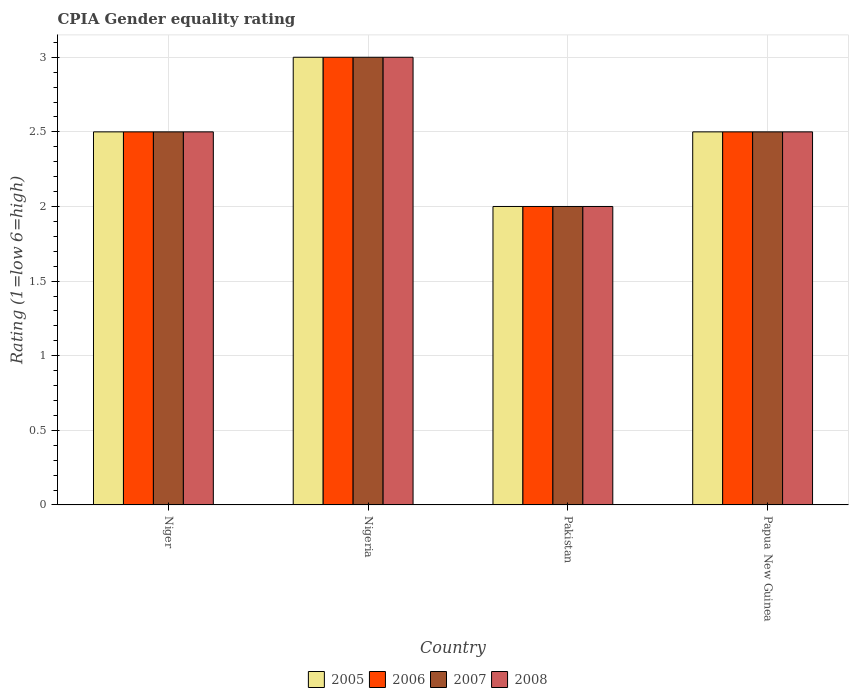How many different coloured bars are there?
Offer a terse response. 4. How many groups of bars are there?
Offer a very short reply. 4. Are the number of bars on each tick of the X-axis equal?
Give a very brief answer. Yes. How many bars are there on the 3rd tick from the left?
Offer a very short reply. 4. What is the label of the 1st group of bars from the left?
Your answer should be very brief. Niger. What is the CPIA rating in 2006 in Pakistan?
Offer a terse response. 2. Across all countries, what is the minimum CPIA rating in 2007?
Keep it short and to the point. 2. In which country was the CPIA rating in 2007 maximum?
Your answer should be compact. Nigeria. What is the difference between the CPIA rating in 2005 in Niger and that in Nigeria?
Your response must be concise. -0.5. What is the difference between the CPIA rating in 2005 in Niger and the CPIA rating in 2006 in Papua New Guinea?
Provide a short and direct response. 0. What is the difference between the CPIA rating of/in 2008 and CPIA rating of/in 2007 in Papua New Guinea?
Your answer should be very brief. 0. In how many countries, is the CPIA rating in 2007 greater than 1.5?
Ensure brevity in your answer.  4. What is the ratio of the CPIA rating in 2007 in Nigeria to that in Papua New Guinea?
Your answer should be very brief. 1.2. What is the difference between the highest and the second highest CPIA rating in 2008?
Offer a very short reply. -0.5. What is the difference between the highest and the lowest CPIA rating in 2007?
Give a very brief answer. 1. Is the sum of the CPIA rating in 2008 in Nigeria and Papua New Guinea greater than the maximum CPIA rating in 2007 across all countries?
Provide a succinct answer. Yes. Is it the case that in every country, the sum of the CPIA rating in 2008 and CPIA rating in 2005 is greater than the sum of CPIA rating in 2007 and CPIA rating in 2006?
Your answer should be very brief. No. What does the 4th bar from the right in Papua New Guinea represents?
Give a very brief answer. 2005. Is it the case that in every country, the sum of the CPIA rating in 2008 and CPIA rating in 2005 is greater than the CPIA rating in 2006?
Your answer should be very brief. Yes. How many bars are there?
Offer a very short reply. 16. Are all the bars in the graph horizontal?
Make the answer very short. No. How many countries are there in the graph?
Ensure brevity in your answer.  4. Does the graph contain grids?
Your answer should be compact. Yes. Where does the legend appear in the graph?
Your answer should be compact. Bottom center. What is the title of the graph?
Provide a succinct answer. CPIA Gender equality rating. Does "2002" appear as one of the legend labels in the graph?
Offer a very short reply. No. What is the label or title of the X-axis?
Offer a very short reply. Country. What is the label or title of the Y-axis?
Make the answer very short. Rating (1=low 6=high). What is the Rating (1=low 6=high) in 2006 in Niger?
Provide a succinct answer. 2.5. What is the Rating (1=low 6=high) of 2007 in Niger?
Ensure brevity in your answer.  2.5. What is the Rating (1=low 6=high) in 2008 in Niger?
Ensure brevity in your answer.  2.5. What is the Rating (1=low 6=high) of 2006 in Nigeria?
Provide a succinct answer. 3. What is the Rating (1=low 6=high) of 2007 in Nigeria?
Your answer should be compact. 3. What is the Rating (1=low 6=high) in 2008 in Pakistan?
Your response must be concise. 2. What is the Rating (1=low 6=high) of 2005 in Papua New Guinea?
Your answer should be compact. 2.5. What is the Rating (1=low 6=high) of 2007 in Papua New Guinea?
Make the answer very short. 2.5. What is the Rating (1=low 6=high) of 2008 in Papua New Guinea?
Offer a terse response. 2.5. Across all countries, what is the maximum Rating (1=low 6=high) of 2005?
Keep it short and to the point. 3. Across all countries, what is the maximum Rating (1=low 6=high) of 2007?
Keep it short and to the point. 3. What is the total Rating (1=low 6=high) of 2007 in the graph?
Ensure brevity in your answer.  10. What is the total Rating (1=low 6=high) in 2008 in the graph?
Your answer should be very brief. 10. What is the difference between the Rating (1=low 6=high) of 2005 in Niger and that in Nigeria?
Provide a succinct answer. -0.5. What is the difference between the Rating (1=low 6=high) in 2006 in Niger and that in Nigeria?
Keep it short and to the point. -0.5. What is the difference between the Rating (1=low 6=high) in 2007 in Niger and that in Nigeria?
Offer a very short reply. -0.5. What is the difference between the Rating (1=low 6=high) in 2005 in Niger and that in Pakistan?
Provide a short and direct response. 0.5. What is the difference between the Rating (1=low 6=high) in 2007 in Niger and that in Pakistan?
Keep it short and to the point. 0.5. What is the difference between the Rating (1=low 6=high) of 2005 in Niger and that in Papua New Guinea?
Make the answer very short. 0. What is the difference between the Rating (1=low 6=high) in 2006 in Niger and that in Papua New Guinea?
Offer a very short reply. 0. What is the difference between the Rating (1=low 6=high) of 2007 in Niger and that in Papua New Guinea?
Your answer should be very brief. 0. What is the difference between the Rating (1=low 6=high) of 2008 in Niger and that in Papua New Guinea?
Ensure brevity in your answer.  0. What is the difference between the Rating (1=low 6=high) in 2005 in Nigeria and that in Pakistan?
Offer a terse response. 1. What is the difference between the Rating (1=low 6=high) of 2008 in Nigeria and that in Pakistan?
Keep it short and to the point. 1. What is the difference between the Rating (1=low 6=high) in 2007 in Nigeria and that in Papua New Guinea?
Your answer should be very brief. 0.5. What is the difference between the Rating (1=low 6=high) of 2008 in Nigeria and that in Papua New Guinea?
Provide a succinct answer. 0.5. What is the difference between the Rating (1=low 6=high) in 2006 in Pakistan and that in Papua New Guinea?
Keep it short and to the point. -0.5. What is the difference between the Rating (1=low 6=high) in 2005 in Niger and the Rating (1=low 6=high) in 2006 in Nigeria?
Provide a short and direct response. -0.5. What is the difference between the Rating (1=low 6=high) of 2005 in Niger and the Rating (1=low 6=high) of 2008 in Nigeria?
Provide a short and direct response. -0.5. What is the difference between the Rating (1=low 6=high) of 2006 in Niger and the Rating (1=low 6=high) of 2007 in Nigeria?
Ensure brevity in your answer.  -0.5. What is the difference between the Rating (1=low 6=high) of 2005 in Niger and the Rating (1=low 6=high) of 2007 in Pakistan?
Provide a short and direct response. 0.5. What is the difference between the Rating (1=low 6=high) in 2006 in Niger and the Rating (1=low 6=high) in 2007 in Pakistan?
Your answer should be compact. 0.5. What is the difference between the Rating (1=low 6=high) of 2006 in Niger and the Rating (1=low 6=high) of 2008 in Pakistan?
Offer a terse response. 0.5. What is the difference between the Rating (1=low 6=high) in 2005 in Niger and the Rating (1=low 6=high) in 2006 in Papua New Guinea?
Offer a terse response. 0. What is the difference between the Rating (1=low 6=high) of 2005 in Niger and the Rating (1=low 6=high) of 2008 in Papua New Guinea?
Keep it short and to the point. 0. What is the difference between the Rating (1=low 6=high) in 2006 in Niger and the Rating (1=low 6=high) in 2007 in Papua New Guinea?
Keep it short and to the point. 0. What is the difference between the Rating (1=low 6=high) in 2006 in Niger and the Rating (1=low 6=high) in 2008 in Papua New Guinea?
Give a very brief answer. 0. What is the difference between the Rating (1=low 6=high) in 2005 in Nigeria and the Rating (1=low 6=high) in 2008 in Pakistan?
Your response must be concise. 1. What is the difference between the Rating (1=low 6=high) in 2007 in Nigeria and the Rating (1=low 6=high) in 2008 in Pakistan?
Your response must be concise. 1. What is the difference between the Rating (1=low 6=high) of 2005 in Nigeria and the Rating (1=low 6=high) of 2006 in Papua New Guinea?
Your response must be concise. 0.5. What is the difference between the Rating (1=low 6=high) of 2005 in Nigeria and the Rating (1=low 6=high) of 2008 in Papua New Guinea?
Offer a very short reply. 0.5. What is the difference between the Rating (1=low 6=high) of 2006 in Nigeria and the Rating (1=low 6=high) of 2007 in Papua New Guinea?
Provide a short and direct response. 0.5. What is the difference between the Rating (1=low 6=high) in 2005 in Pakistan and the Rating (1=low 6=high) in 2006 in Papua New Guinea?
Make the answer very short. -0.5. What is the difference between the Rating (1=low 6=high) of 2006 in Pakistan and the Rating (1=low 6=high) of 2007 in Papua New Guinea?
Give a very brief answer. -0.5. What is the average Rating (1=low 6=high) of 2005 per country?
Give a very brief answer. 2.5. What is the average Rating (1=low 6=high) in 2007 per country?
Your response must be concise. 2.5. What is the average Rating (1=low 6=high) in 2008 per country?
Give a very brief answer. 2.5. What is the difference between the Rating (1=low 6=high) of 2005 and Rating (1=low 6=high) of 2007 in Niger?
Your response must be concise. 0. What is the difference between the Rating (1=low 6=high) of 2007 and Rating (1=low 6=high) of 2008 in Niger?
Keep it short and to the point. 0. What is the difference between the Rating (1=low 6=high) in 2007 and Rating (1=low 6=high) in 2008 in Nigeria?
Your response must be concise. 0. What is the difference between the Rating (1=low 6=high) of 2005 and Rating (1=low 6=high) of 2006 in Pakistan?
Ensure brevity in your answer.  0. What is the difference between the Rating (1=low 6=high) in 2005 and Rating (1=low 6=high) in 2007 in Pakistan?
Provide a succinct answer. 0. What is the difference between the Rating (1=low 6=high) of 2005 and Rating (1=low 6=high) of 2006 in Papua New Guinea?
Offer a very short reply. 0. What is the difference between the Rating (1=low 6=high) of 2006 and Rating (1=low 6=high) of 2007 in Papua New Guinea?
Keep it short and to the point. 0. What is the ratio of the Rating (1=low 6=high) in 2005 in Niger to that in Nigeria?
Your answer should be compact. 0.83. What is the ratio of the Rating (1=low 6=high) of 2006 in Niger to that in Nigeria?
Your answer should be very brief. 0.83. What is the ratio of the Rating (1=low 6=high) in 2005 in Niger to that in Pakistan?
Your answer should be very brief. 1.25. What is the ratio of the Rating (1=low 6=high) in 2006 in Niger to that in Pakistan?
Provide a short and direct response. 1.25. What is the ratio of the Rating (1=low 6=high) of 2008 in Niger to that in Papua New Guinea?
Keep it short and to the point. 1. What is the ratio of the Rating (1=low 6=high) in 2006 in Nigeria to that in Pakistan?
Your response must be concise. 1.5. What is the ratio of the Rating (1=low 6=high) in 2007 in Nigeria to that in Pakistan?
Provide a succinct answer. 1.5. What is the ratio of the Rating (1=low 6=high) of 2008 in Nigeria to that in Pakistan?
Offer a terse response. 1.5. What is the ratio of the Rating (1=low 6=high) in 2006 in Nigeria to that in Papua New Guinea?
Offer a very short reply. 1.2. What is the ratio of the Rating (1=low 6=high) in 2007 in Nigeria to that in Papua New Guinea?
Keep it short and to the point. 1.2. What is the ratio of the Rating (1=low 6=high) of 2008 in Nigeria to that in Papua New Guinea?
Your answer should be compact. 1.2. What is the ratio of the Rating (1=low 6=high) in 2007 in Pakistan to that in Papua New Guinea?
Your response must be concise. 0.8. What is the ratio of the Rating (1=low 6=high) of 2008 in Pakistan to that in Papua New Guinea?
Keep it short and to the point. 0.8. What is the difference between the highest and the second highest Rating (1=low 6=high) in 2005?
Offer a terse response. 0.5. What is the difference between the highest and the second highest Rating (1=low 6=high) of 2007?
Give a very brief answer. 0.5. What is the difference between the highest and the lowest Rating (1=low 6=high) of 2005?
Provide a short and direct response. 1. What is the difference between the highest and the lowest Rating (1=low 6=high) of 2007?
Make the answer very short. 1. What is the difference between the highest and the lowest Rating (1=low 6=high) of 2008?
Make the answer very short. 1. 